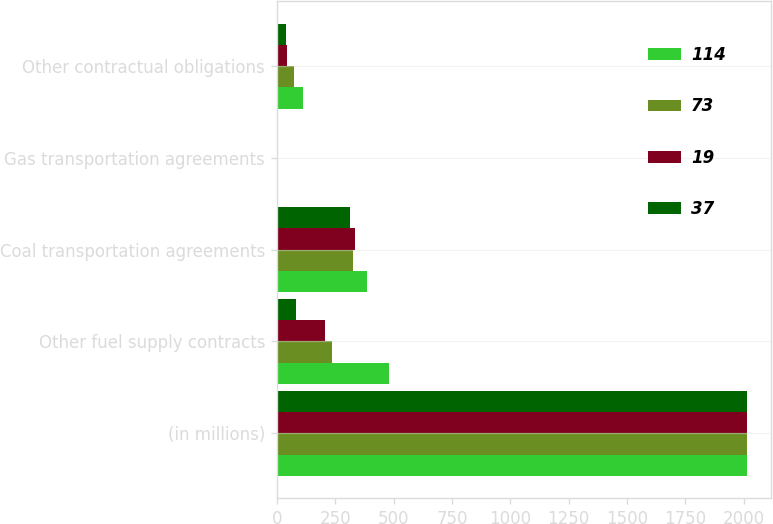<chart> <loc_0><loc_0><loc_500><loc_500><stacked_bar_chart><ecel><fcel>(in millions)<fcel>Other fuel supply contracts<fcel>Coal transportation agreements<fcel>Gas transportation agreements<fcel>Other contractual obligations<nl><fcel>114<fcel>2012<fcel>479<fcel>386<fcel>7<fcel>114<nl><fcel>73<fcel>2013<fcel>237<fcel>326<fcel>7<fcel>73<nl><fcel>19<fcel>2014<fcel>208<fcel>333<fcel>7<fcel>43<nl><fcel>37<fcel>2015<fcel>83<fcel>315<fcel>7<fcel>37<nl></chart> 